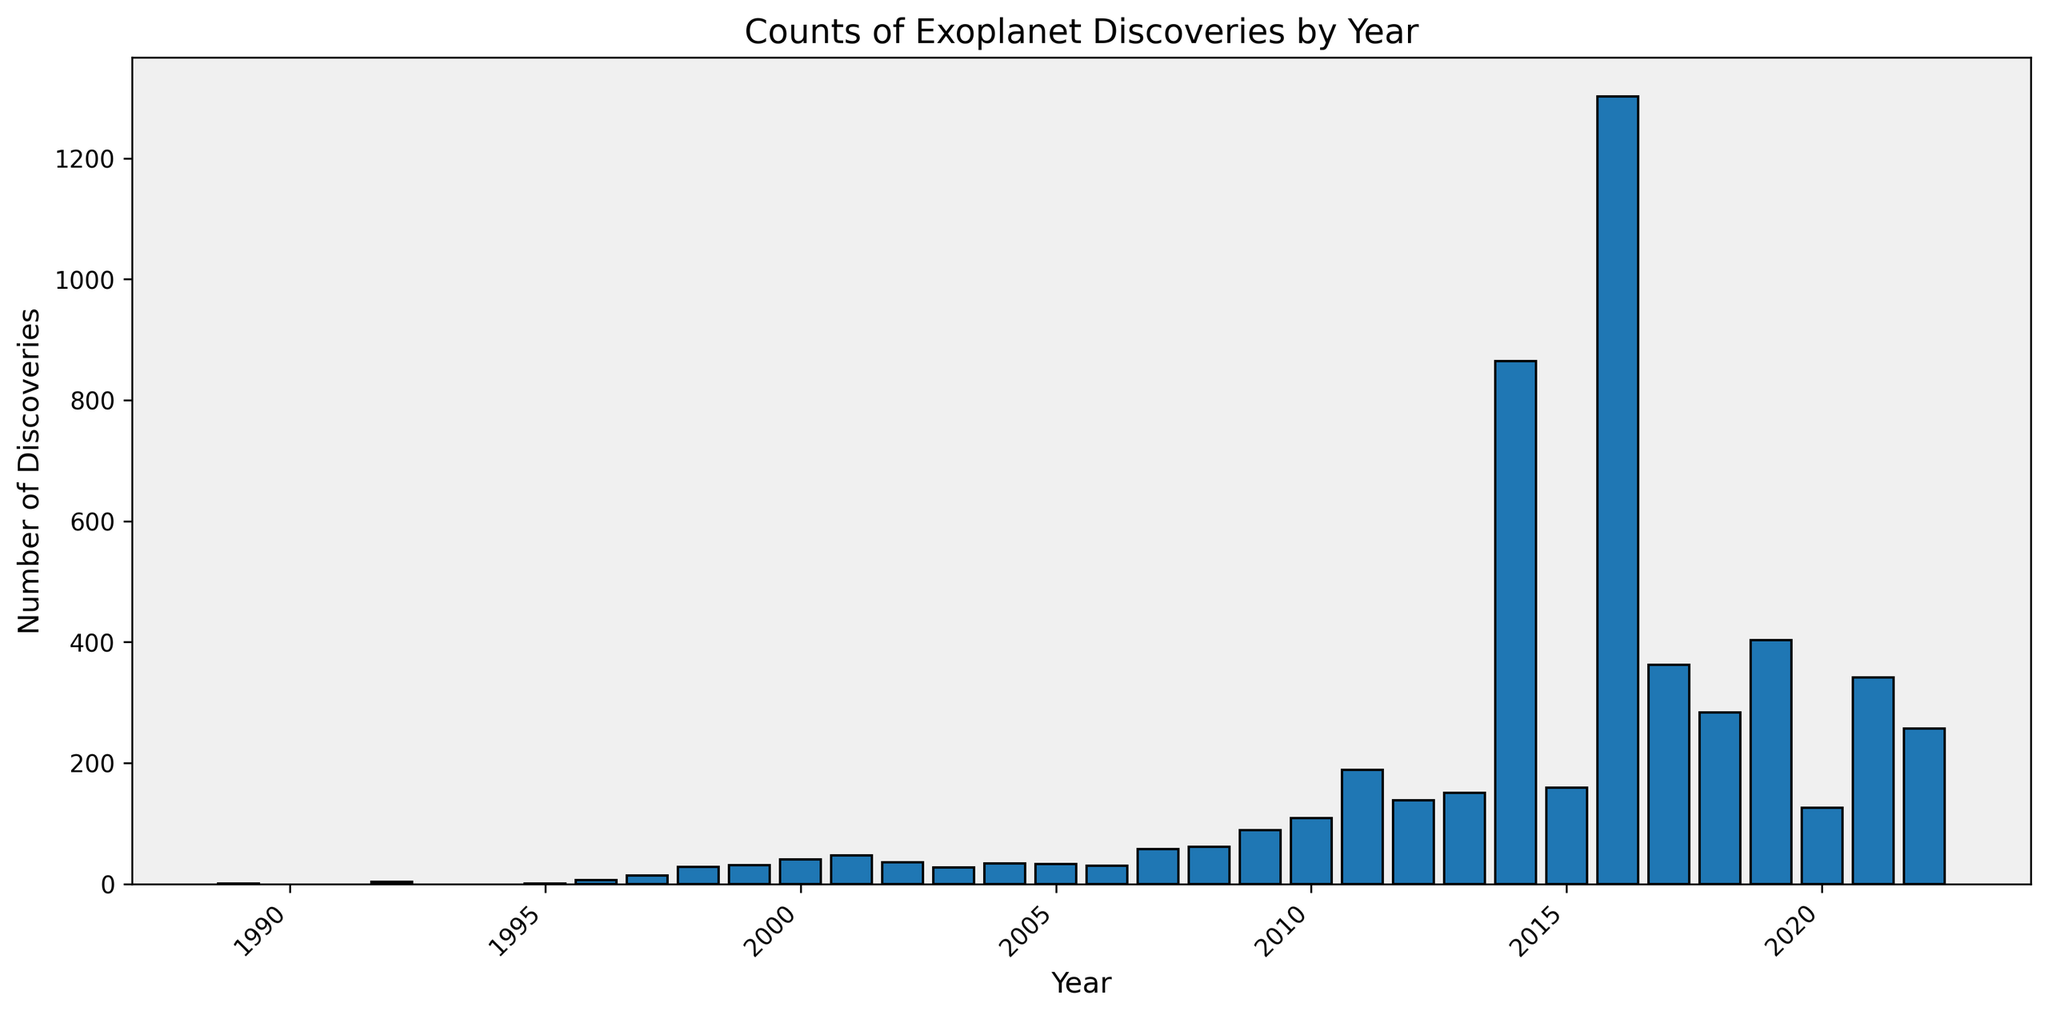what is the total number of exoplanet discoveries from 2014 to 2016? Sum up the number of discoveries for the years 2014, 2015, and 2016: 865 + 159 + 1302 = 2326
Answer: 2326 which year had the highest number of exoplanet discoveries? Scan through the bars to identify the one that is tallest. The year 2016 has the highest bar with 1302 discoveries.
Answer: 2016 how does the number of discoveries in 2007 compare to 2008? Refer to the height of the bars for 2007 and 2008. In 2007, there are 58 discoveries, and in 2008, there are 61 discoveries. 61 > 58
Answer: More in 2008 what is the average number of discoveries per year from 1996 to 2000? Calculate the average by summing the discoveries from 1996 to 2000 and dividing by the number of years: (6 + 14 + 28 + 31 + 40) / 5 = 119 / 5 = 23.8
Answer: 23.8 how do the discoveries in 2016 and 2017 together compare to 2018? Sum the discoveries for 2016 and 2017 and compare to 2018: 1302 + 362 = 1664 (in 2016 and 2017) and 284 in 2018. 1664 > 284
Answer: 2016 and 2017 together is more which years had fewer than 10 discoveries? Identify the bars with heights less than 10. These are the years 1989 (1 discovery), 1992 (3), 1995 (1), and 1996 (6).
Answer: 1989, 1992, 1995, 1996 are there any years where discoveries stagnated or decreased compared to the previous year? Provide one such instance. Compare the heights of the bars year by year. For example, from 2012 (138 discoveries) to 2013 (151 discoveries) increased, but from 2014 (865 discoveries) to 2015 (159 discoveries) decreased.
Answer: 2014 to 2015 what is the total number of discoveries made in the first 10 years depicted in the graph (from 1989 to 1998)? Sum the discoveries from 1989 to 1998: 1 + 3 + 1 + 6 + 14 + 28 + 31 + 40 + 47 + 36 = 207
Answer: 207 